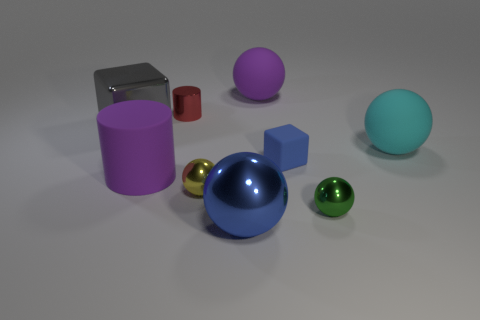What materials are the objects in this image made of, and how can you differentiate between them? The objects in the image display varied materials with distinct visual properties. The matte objects, such as the large purple cylinder and the blue cube, absorb and scatter light evenly, giving them a flat, non-reflective appearance. In contrast, the metal spheres have a reflective sheen and highlight reflections that indicate their glossy, metallic nature. These visual clues help us differentiate the materials effectively. 